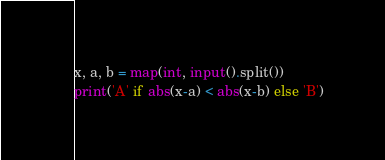<code> <loc_0><loc_0><loc_500><loc_500><_Python_>x, a, b = map(int, input().split())
print('A' if abs(x-a) < abs(x-b) else 'B')</code> 